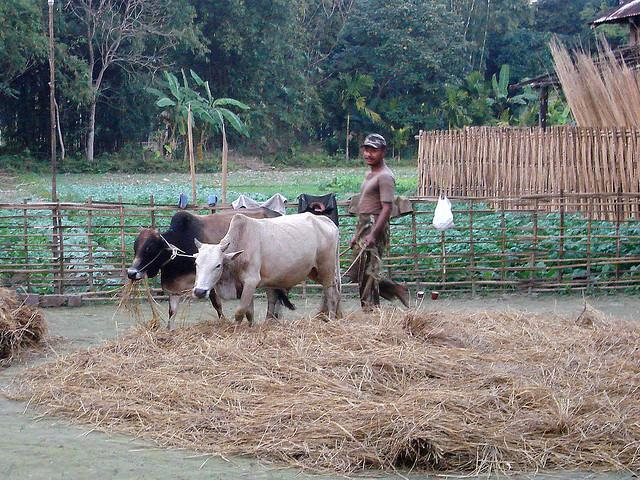What diet are the cows here on?

Choices:
A) vegan
B) carnivorous
C) milk
D) fasting vegan 